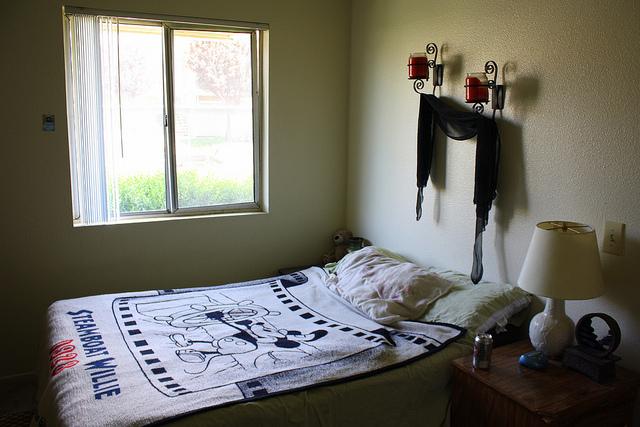Is the bed made or unmade?
Be succinct. Made. What is the theme of the bedspread?
Quick response, please. Steamboat willie. Is there blinds or curtains near the window?
Keep it brief. Yes. 